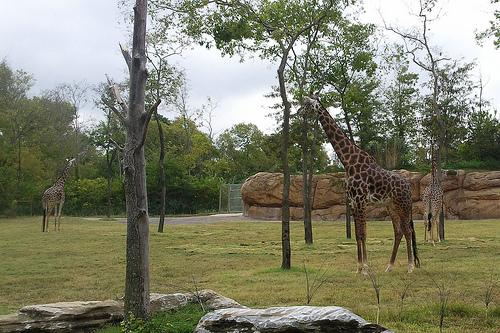- Giraffes: Tall animals with spots, long necks, and tails. - Sky: Blue, cloudy, and white clouds. 1. Giraffes: Tall, with spots, long necks, and tails. 3. Grass: Green, short, and dry in some areas. Is the grass very tall and blue in color? The grass is described as short and green, not tall and blue, so this statement is misleading. Is the sky green in the image? The sky is described as blue and cloudy, but not green, so this statement is misleading. Are the leaves on the tree orange? The leaves on the tree are described as green, not orange, so this instruction is misleading. Are there any elephants in the scene? There are only giraffes mentioned in the scene, so asking about elephants is misleading. Does the giraffe have a very short tail? The giraffe's tail is described as very long and black, not short, so this instruction is misleading. Do the rocks have purple spots on them? There is no mention of any spots on rocks or the color purple, so this statement is misleading. 